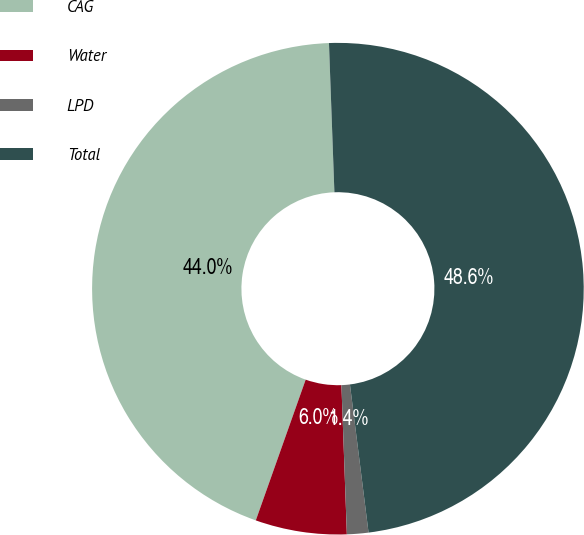Convert chart to OTSL. <chart><loc_0><loc_0><loc_500><loc_500><pie_chart><fcel>CAG<fcel>Water<fcel>LPD<fcel>Total<nl><fcel>44.0%<fcel>6.0%<fcel>1.41%<fcel>48.59%<nl></chart> 